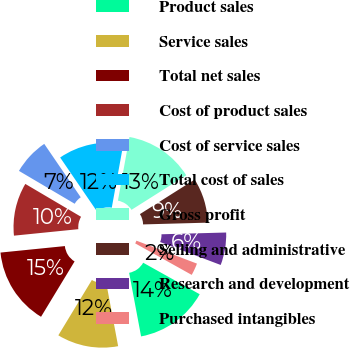<chart> <loc_0><loc_0><loc_500><loc_500><pie_chart><fcel>Product sales<fcel>Service sales<fcel>Total net sales<fcel>Cost of product sales<fcel>Cost of service sales<fcel>Total cost of sales<fcel>Gross profit<fcel>Selling and administrative<fcel>Research and development<fcel>Purchased intangibles<nl><fcel>13.95%<fcel>11.63%<fcel>14.73%<fcel>10.08%<fcel>6.98%<fcel>12.4%<fcel>13.18%<fcel>8.53%<fcel>6.2%<fcel>2.33%<nl></chart> 